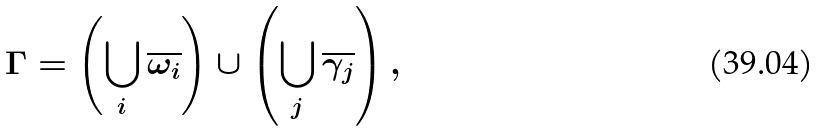<formula> <loc_0><loc_0><loc_500><loc_500>\Gamma = \left ( \bigcup _ { i } \overline { \omega _ { i } } \right ) \cup \left ( \bigcup _ { j } \overline { \gamma _ { j } } \right ) ,</formula> 